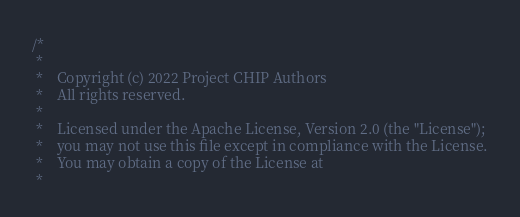Convert code to text. <code><loc_0><loc_0><loc_500><loc_500><_ObjectiveC_>/*
 *
 *    Copyright (c) 2022 Project CHIP Authors
 *    All rights reserved.
 *
 *    Licensed under the Apache License, Version 2.0 (the "License");
 *    you may not use this file except in compliance with the License.
 *    You may obtain a copy of the License at
 *</code> 